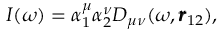<formula> <loc_0><loc_0><loc_500><loc_500>I ( \omega ) = \alpha _ { 1 } ^ { \mu } \alpha _ { 2 } ^ { \nu } D _ { \mu \nu } ( \omega , \pm b { r } _ { 1 2 } ) ,</formula> 